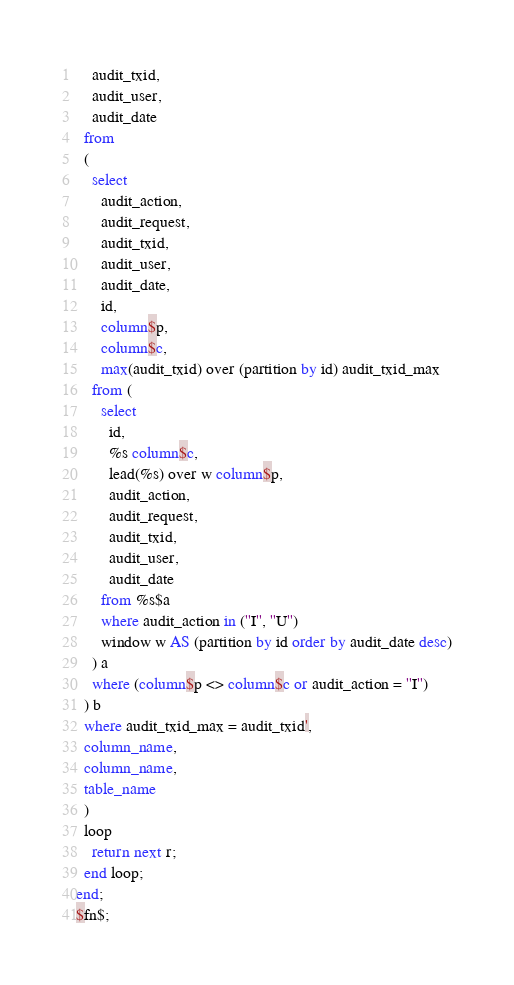Convert code to text. <code><loc_0><loc_0><loc_500><loc_500><_SQL_>    audit_txid,
    audit_user,
    audit_date
  from 
  (
    select 
      audit_action,
      audit_request,  
      audit_txid,
      audit_user,
      audit_date,
      id,
      column$p,
      column$c,
      max(audit_txid) over (partition by id) audit_txid_max
    from (
      select 
        id,
        %s column$c,
        lead(%s) over w column$p,
        audit_action,
        audit_request,  
        audit_txid,
        audit_user,
        audit_date
      from %s$a
      where audit_action in (''I'', ''U'')
      window w AS (partition by id order by audit_date desc)
    ) a
    where (column$p <> column$c or audit_action = ''I'')
  ) b
  where audit_txid_max = audit_txid',
  column_name,
  column_name,
  table_name
  )
  loop
    return next r;
  end loop;  
end;
$fn$;
</code> 